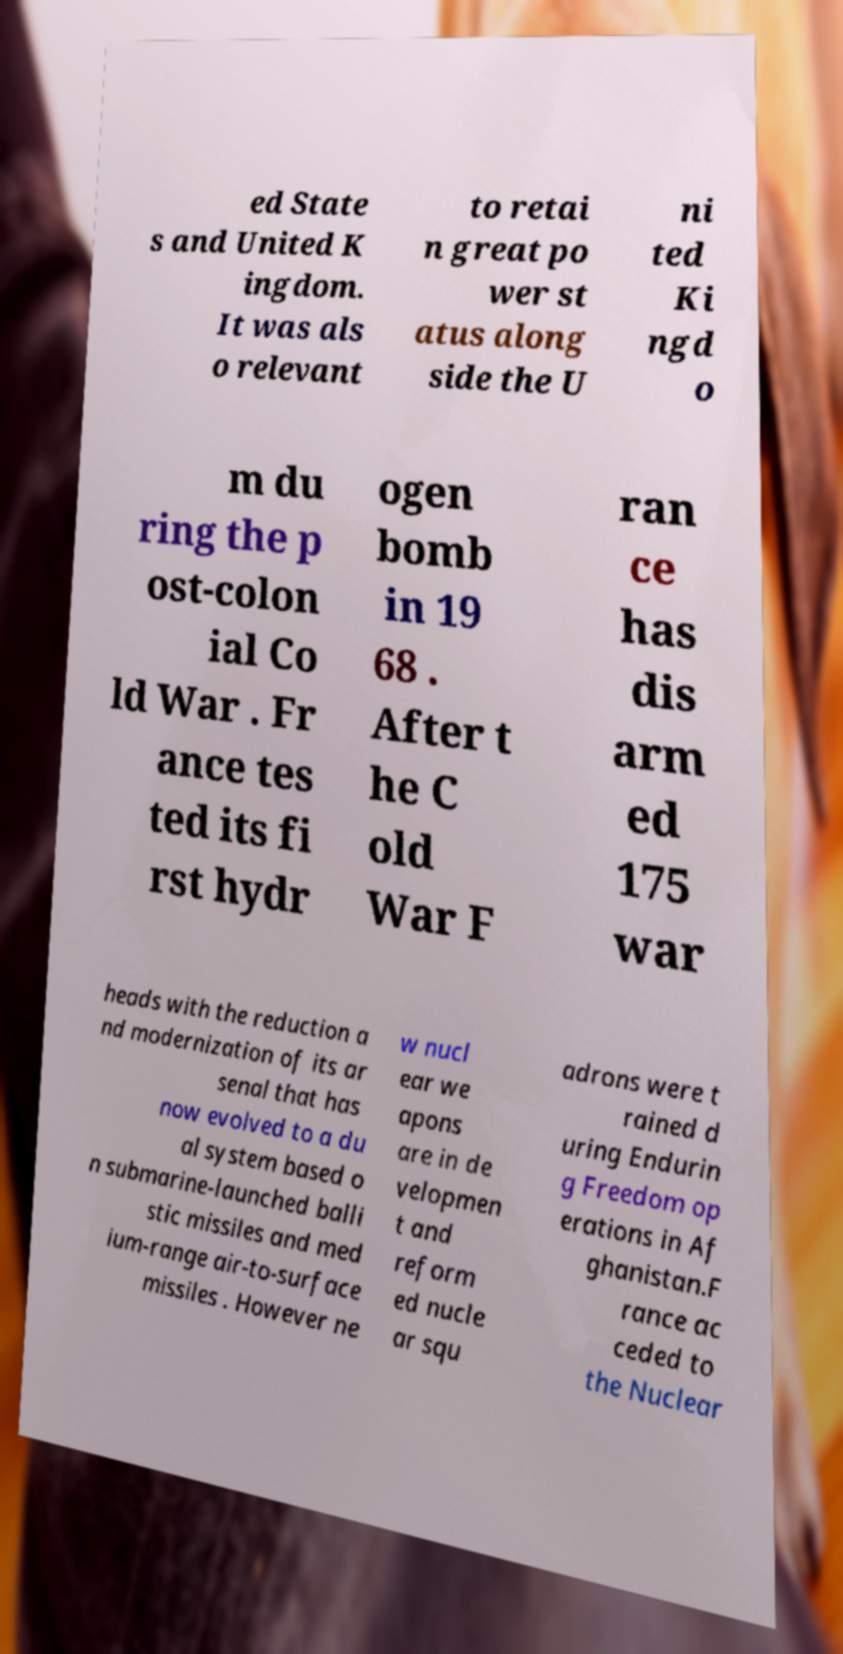For documentation purposes, I need the text within this image transcribed. Could you provide that? ed State s and United K ingdom. It was als o relevant to retai n great po wer st atus along side the U ni ted Ki ngd o m du ring the p ost-colon ial Co ld War . Fr ance tes ted its fi rst hydr ogen bomb in 19 68 . After t he C old War F ran ce has dis arm ed 175 war heads with the reduction a nd modernization of its ar senal that has now evolved to a du al system based o n submarine-launched balli stic missiles and med ium-range air-to-surface missiles . However ne w nucl ear we apons are in de velopmen t and reform ed nucle ar squ adrons were t rained d uring Endurin g Freedom op erations in Af ghanistan.F rance ac ceded to the Nuclear 